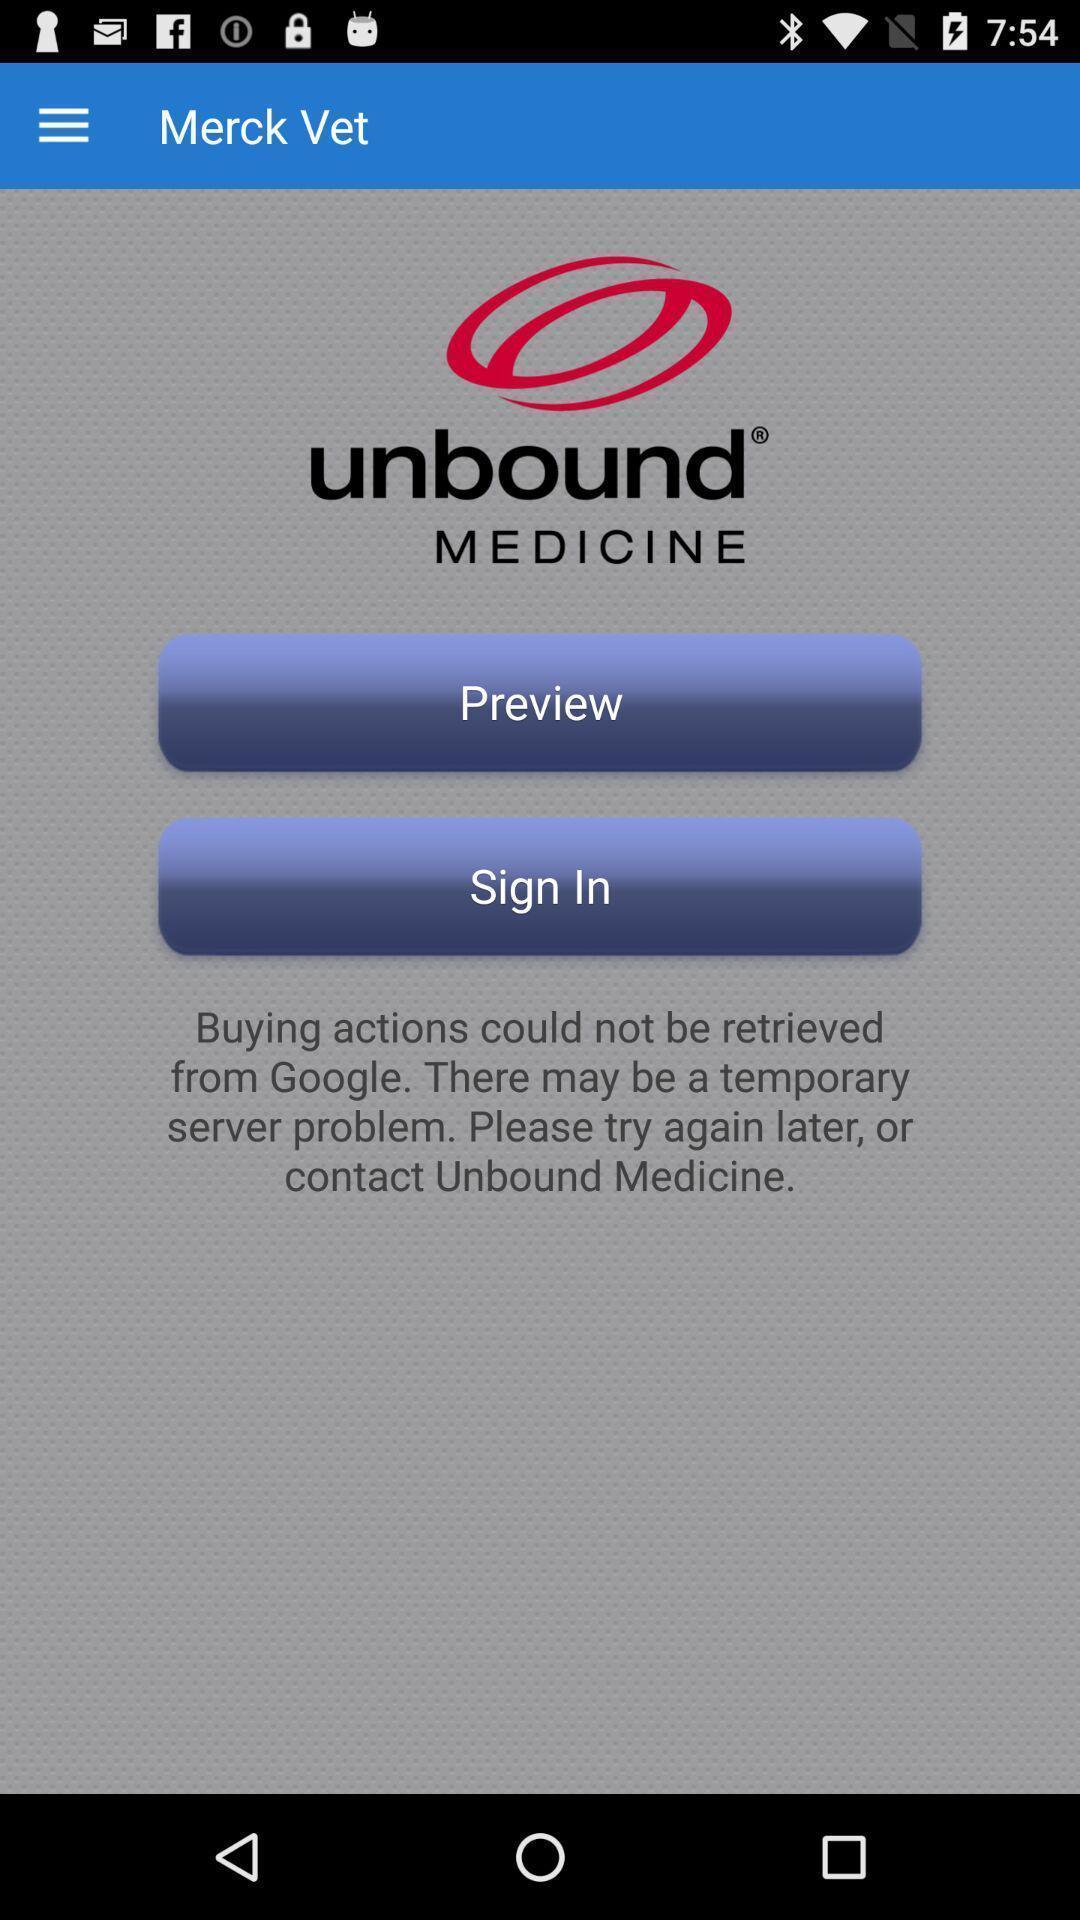Summarize the main components in this picture. Sign in page s. 